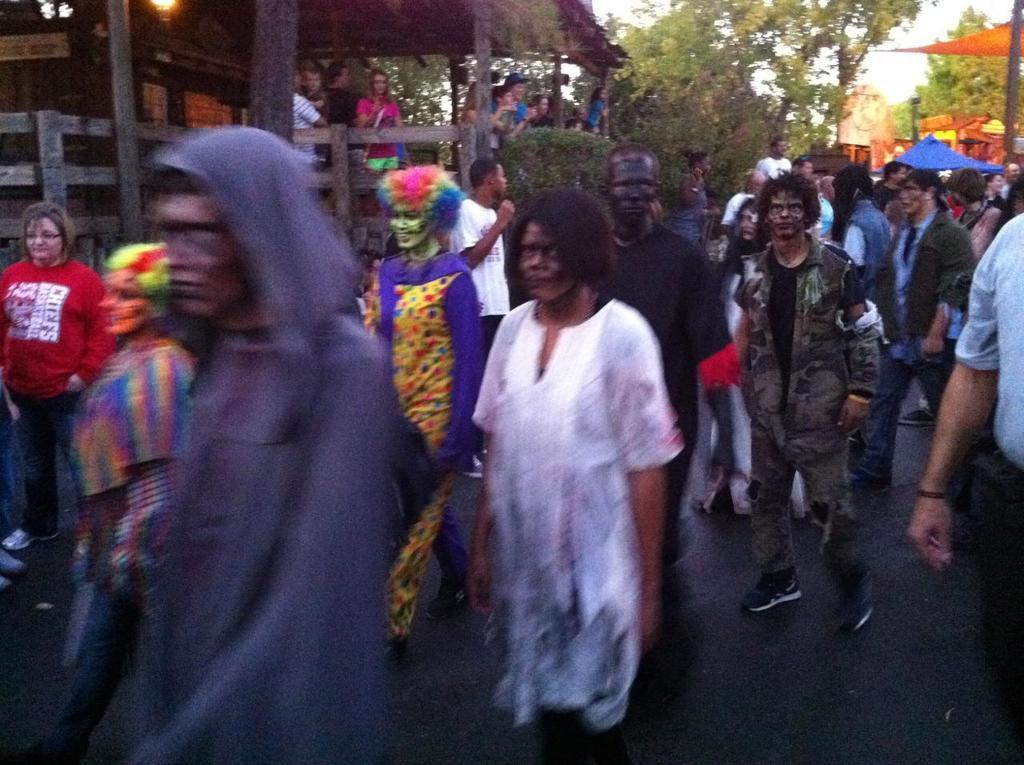What can be observed about the attire of the persons in the image? There are persons in different color dresses in the image. What is the emotional state of some of the persons in the image? Some of the persons are smiling. Where does the scene take place? The scene takes place on a road. What can be seen in the background of the image? There are trees, a building, and clouds visible in the sky in the background of the image. What day is it in the image? There is no information about the day in the image. 